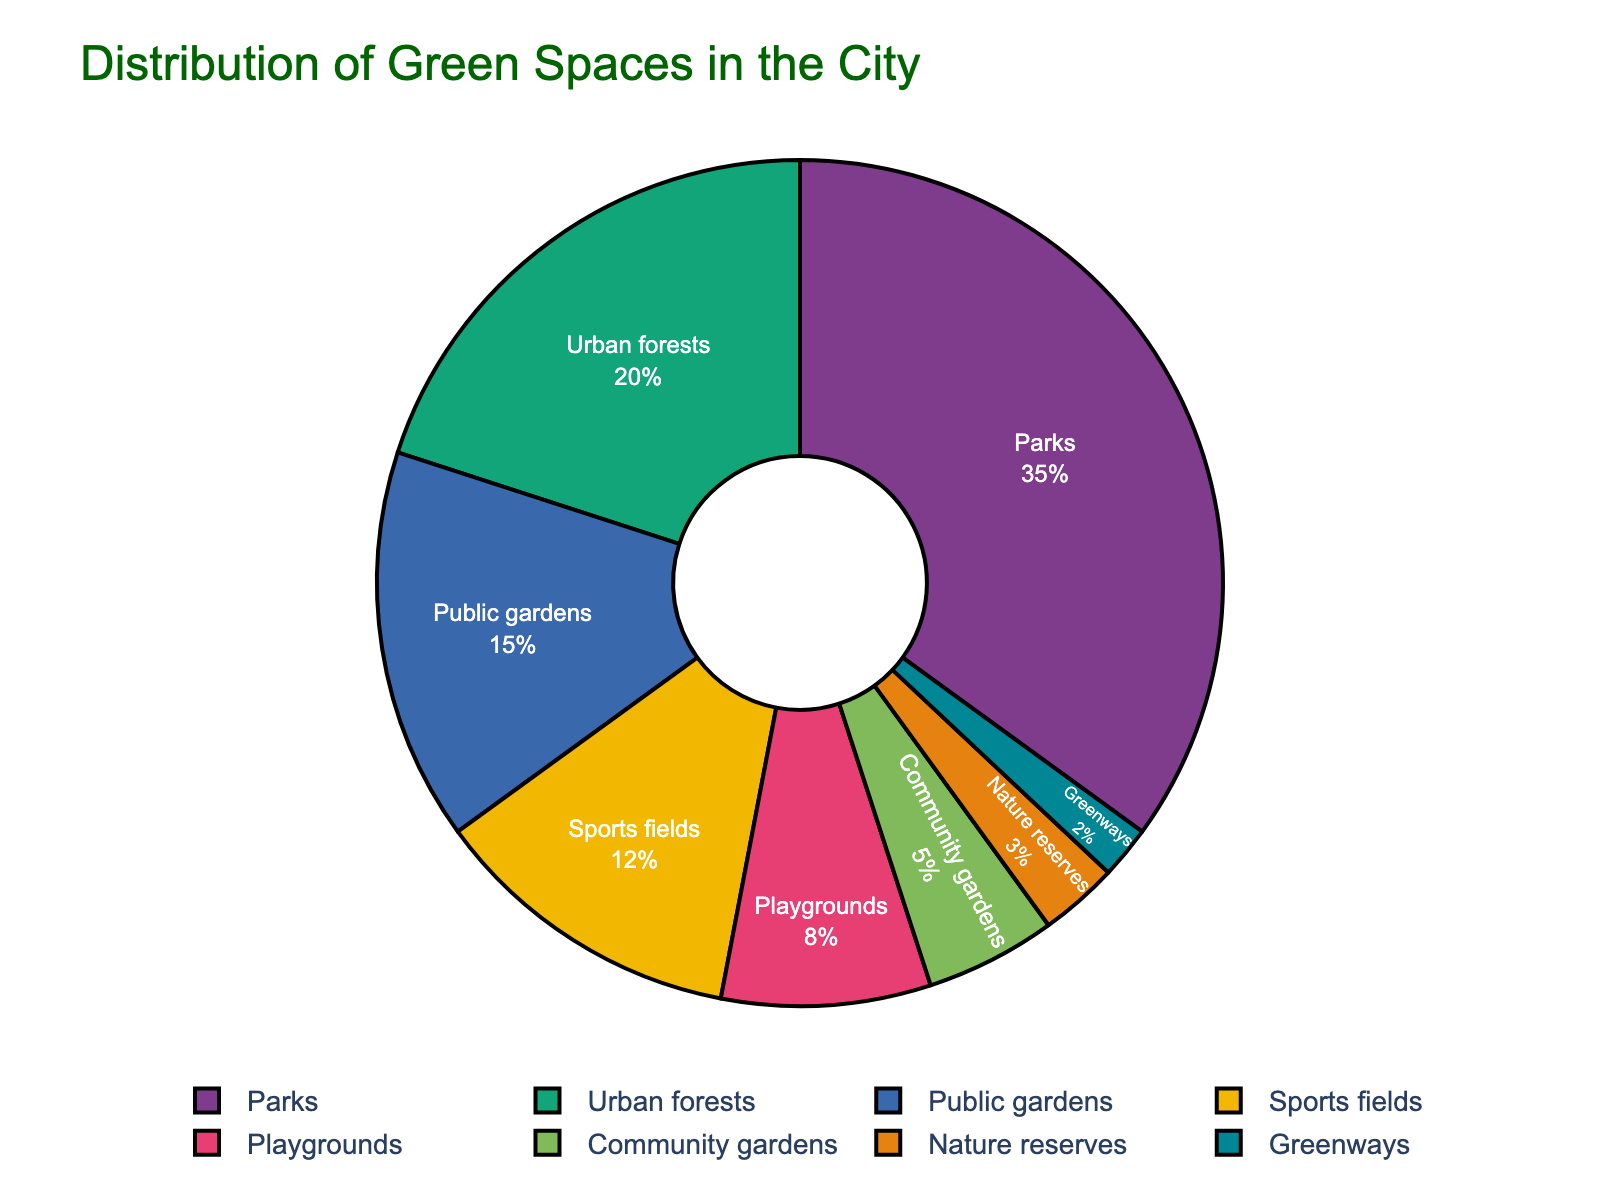What's the most common type of green space in the city? The pie chart showcases different green spaces and indicates their percentage distribution. The largest segment of the pie chart represents the most common type. Here, Parks have the highest percentage at 35%.
Answer: Parks Which type of green space occupies the smallest area within city limits? To identify the green space that occupies the smallest area, look for the smallest segment of the pie chart. According to the figure, Greenways have the smallest percentage at 2%.
Answer: Greenways How much more area do Parks occupy compared to Playgrounds? To find out how much more area Parks occupy compared to Playgrounds, subtract the percentage of Playgrounds from the percentage of Parks: 35% - 8% = 27%. So, Parks occupy 27% more area than Playgrounds.
Answer: 27% What is the combined percentage of area occupied by Urban forests and Public gardens? To determine the combined percentage, simply add the percentages of Urban forests and Public gardens: 20% + 15% = 35%.
Answer: 35% Are there more Sports fields or Community gardens? By comparing the segments representing Sports fields and Community gardens, we see that Sports fields have a larger percentage (12%) than Community gardens (5%).
Answer: Sports fields What is the difference in area between Nature reserves and Playgrounds? Subtract the percentage of Nature reserves from the percentage of Playgrounds to find the difference: 8% - 3% = 5%. Therefore, Playgrounds occupy 5% more area than Nature reserves.
Answer: 5% Which type of green space is represented by the dark green color? By referring to the segment colors in the pie chart, identify the segment with a dark green shade. Assuming the color sequence, Urban forests might be represented by dark green at 20%.
Answer: Urban forests How much area do Community gardens and Nature reserves together take up, excluding Urban forests? Add the percentages of Community gardens and Nature reserves: 5% + 3% = 8%. Urban forests are not included in this calculation.
Answer: 8% Do Urban forests occupy more area than Public gardens and Sports fields combined? First, find the combined percentage of Public gardens and Sports fields: 15% + 12% = 27%. Urban forests occupy 20%, which is less than 27%.
Answer: No 